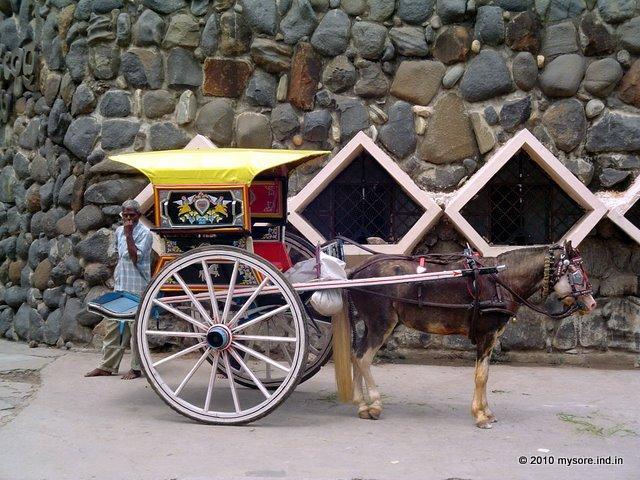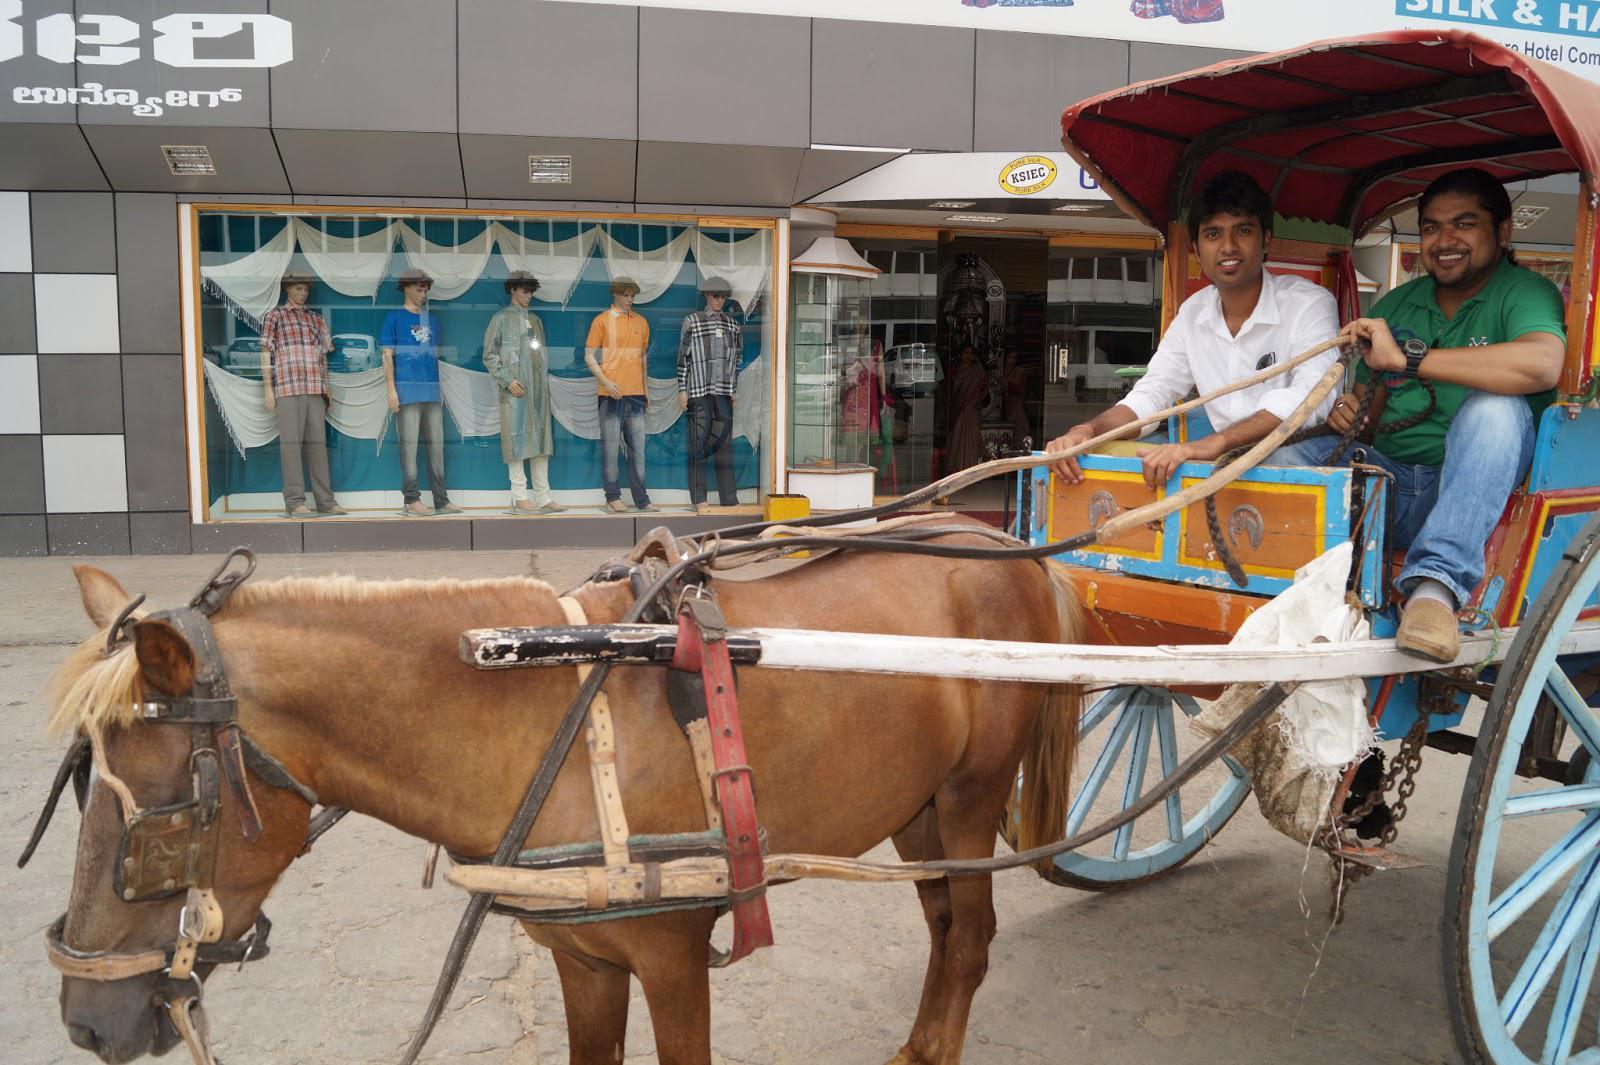The first image is the image on the left, the second image is the image on the right. Examine the images to the left and right. Is the description "The left and right image contains a total of two horses." accurate? Answer yes or no. Yes. The first image is the image on the left, the second image is the image on the right. Assess this claim about the two images: "The right image shows a four-wheeled white carriage with some type of top, pulled by one horse facing leftward.". Correct or not? Answer yes or no. No. 